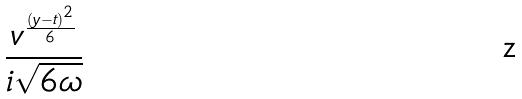Convert formula to latex. <formula><loc_0><loc_0><loc_500><loc_500>\frac { v ^ { \frac { ( y - t ) ^ { 2 } } { 6 } } } { i \sqrt { 6 \omega } }</formula> 